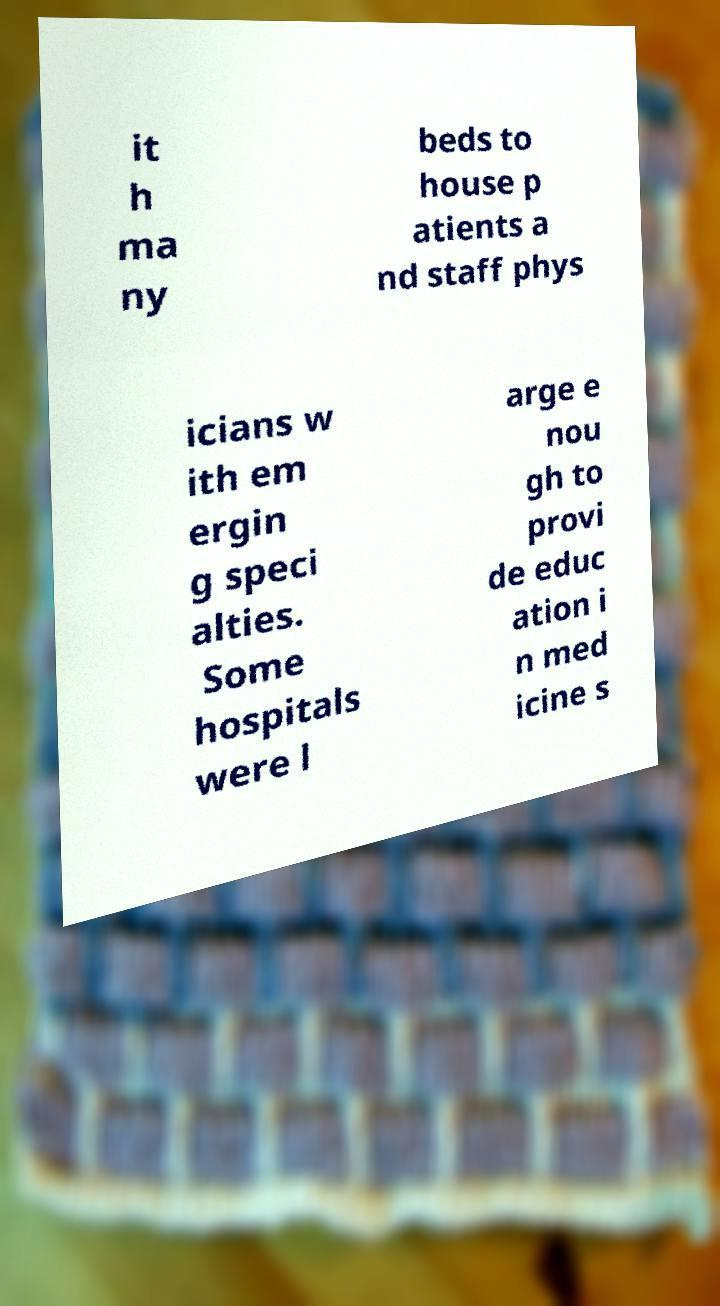Please identify and transcribe the text found in this image. it h ma ny beds to house p atients a nd staff phys icians w ith em ergin g speci alties. Some hospitals were l arge e nou gh to provi de educ ation i n med icine s 